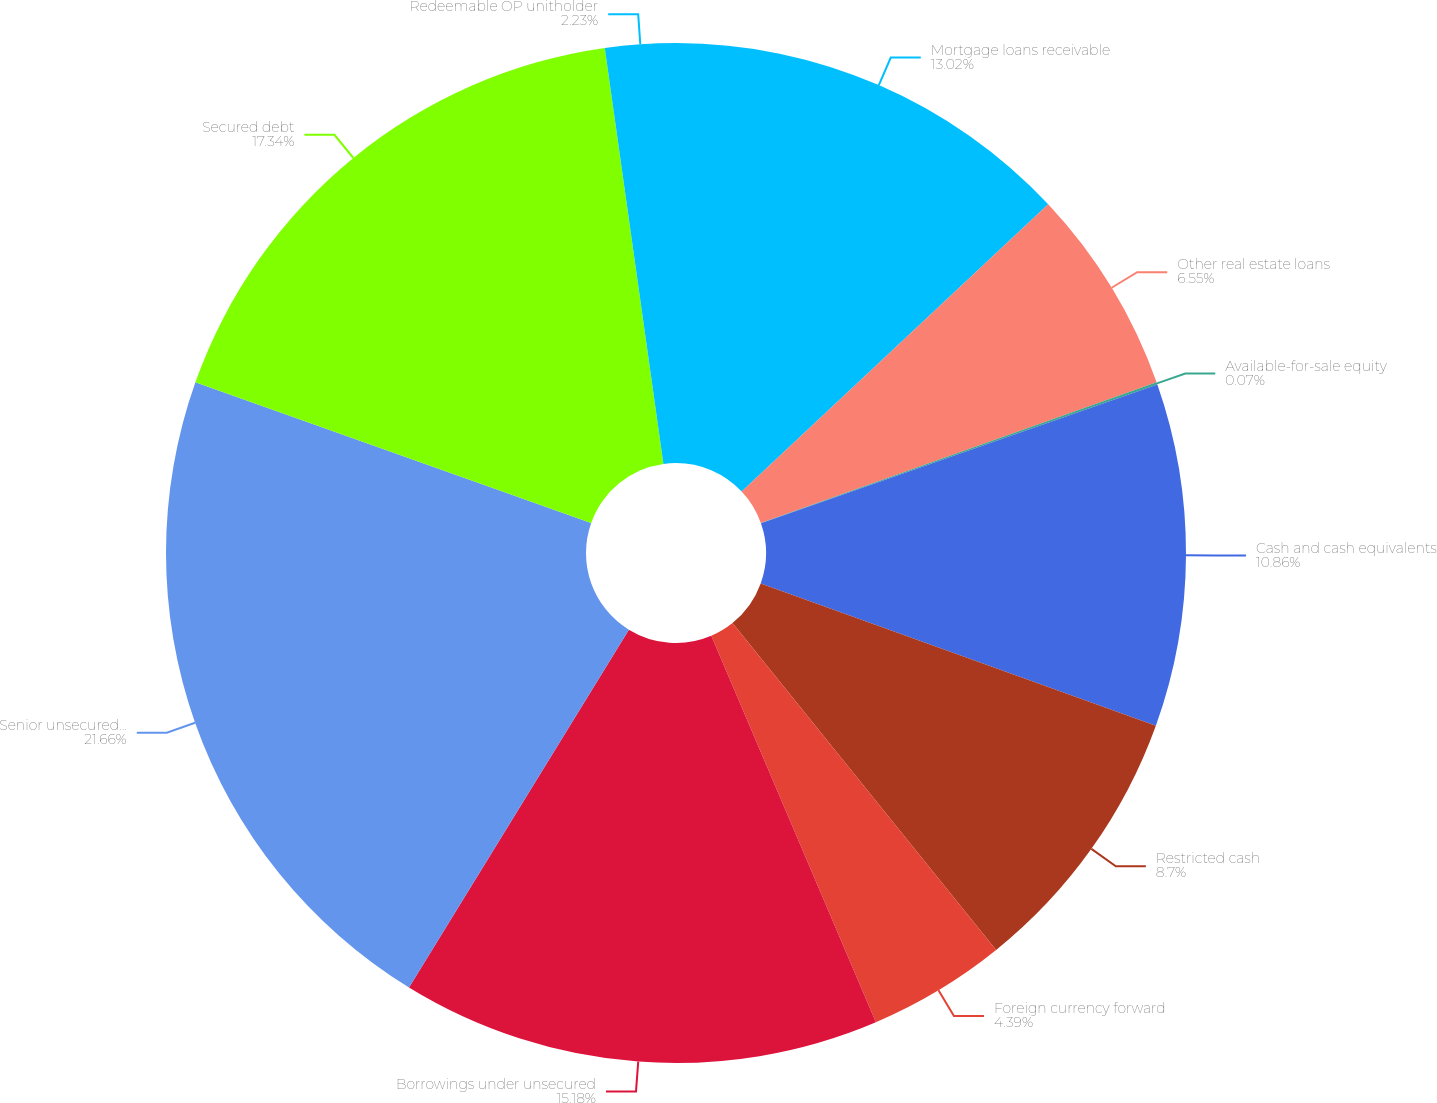<chart> <loc_0><loc_0><loc_500><loc_500><pie_chart><fcel>Mortgage loans receivable<fcel>Other real estate loans<fcel>Available-for-sale equity<fcel>Cash and cash equivalents<fcel>Restricted cash<fcel>Foreign currency forward<fcel>Borrowings under unsecured<fcel>Senior unsecured notes<fcel>Secured debt<fcel>Redeemable OP unitholder<nl><fcel>13.02%<fcel>6.55%<fcel>0.07%<fcel>10.86%<fcel>8.7%<fcel>4.39%<fcel>15.18%<fcel>21.66%<fcel>17.34%<fcel>2.23%<nl></chart> 